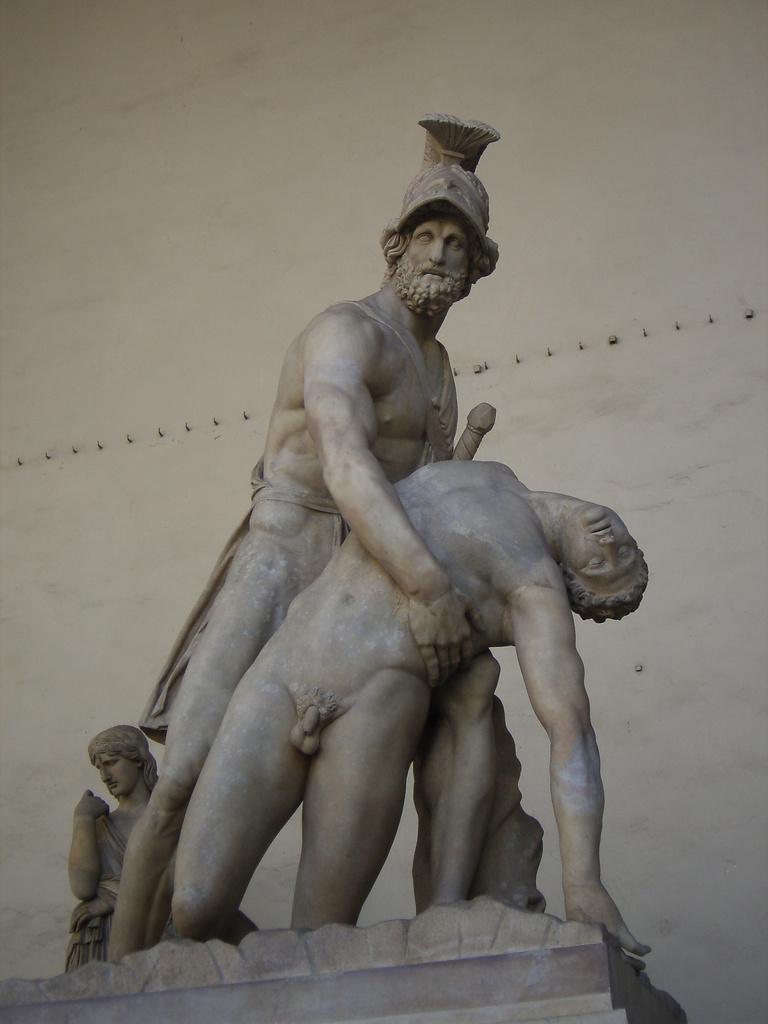Describe this image in one or two sentences. In this image we can see one big statue, where is the white background and some objects on the surface. 